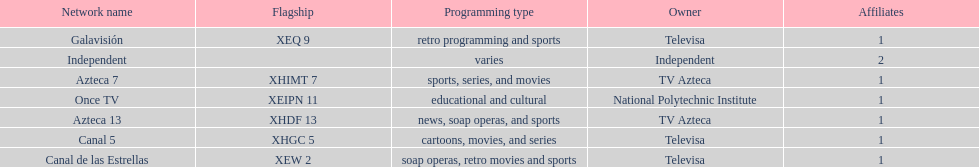Who is the only network owner listed in a consecutive order in the chart? Televisa. 